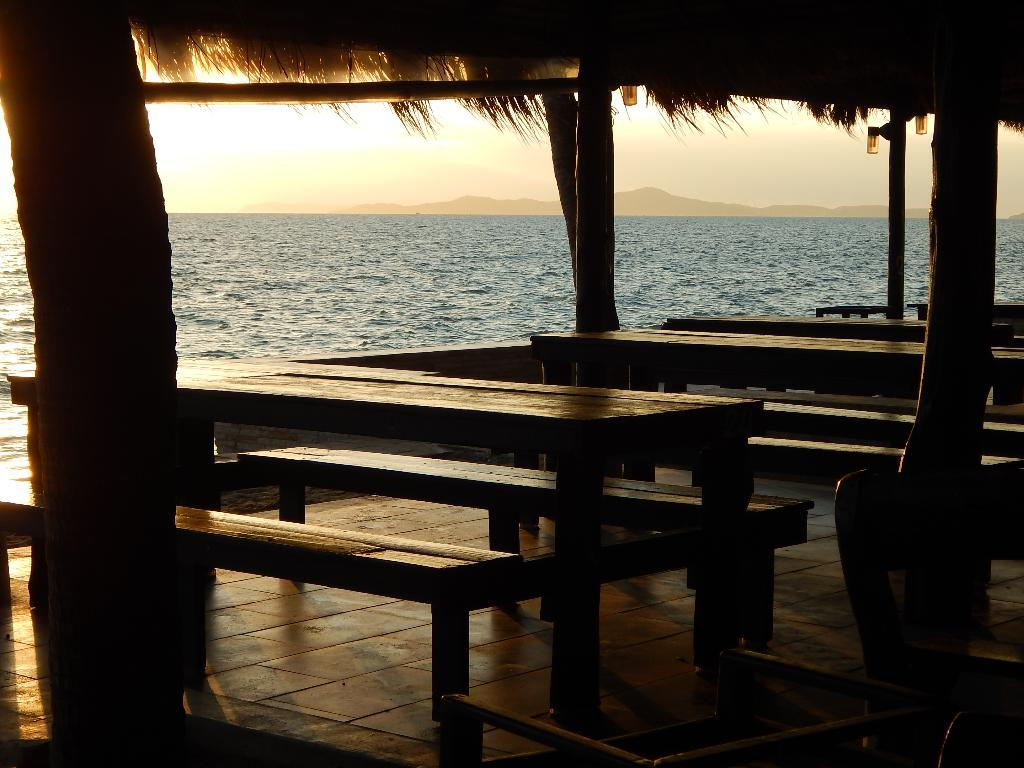What type of furniture is present in the hut? There are tables and benches in the hut. What architectural elements can be seen in the image? There are pillars in the image. What can be seen in the background of the image? There is an ocean, hills, and the sky visible in the background. Can you tell me how many drops of water are on the table in the image? There is no mention of drops of water on the table in the image, so it cannot be determined. Is there a stranger present in the image? There is no stranger mentioned or visible in the image. 